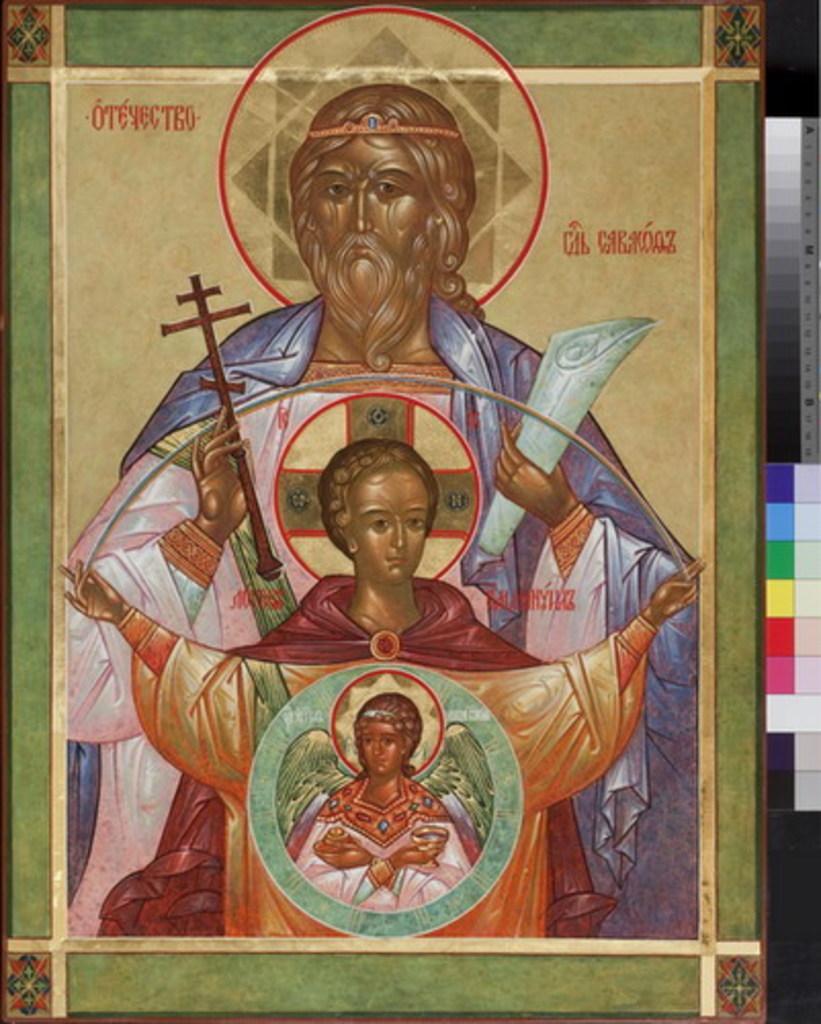In one or two sentences, can you explain what this image depicts? In this picture we can see the painting of three people and some objects on a board. 